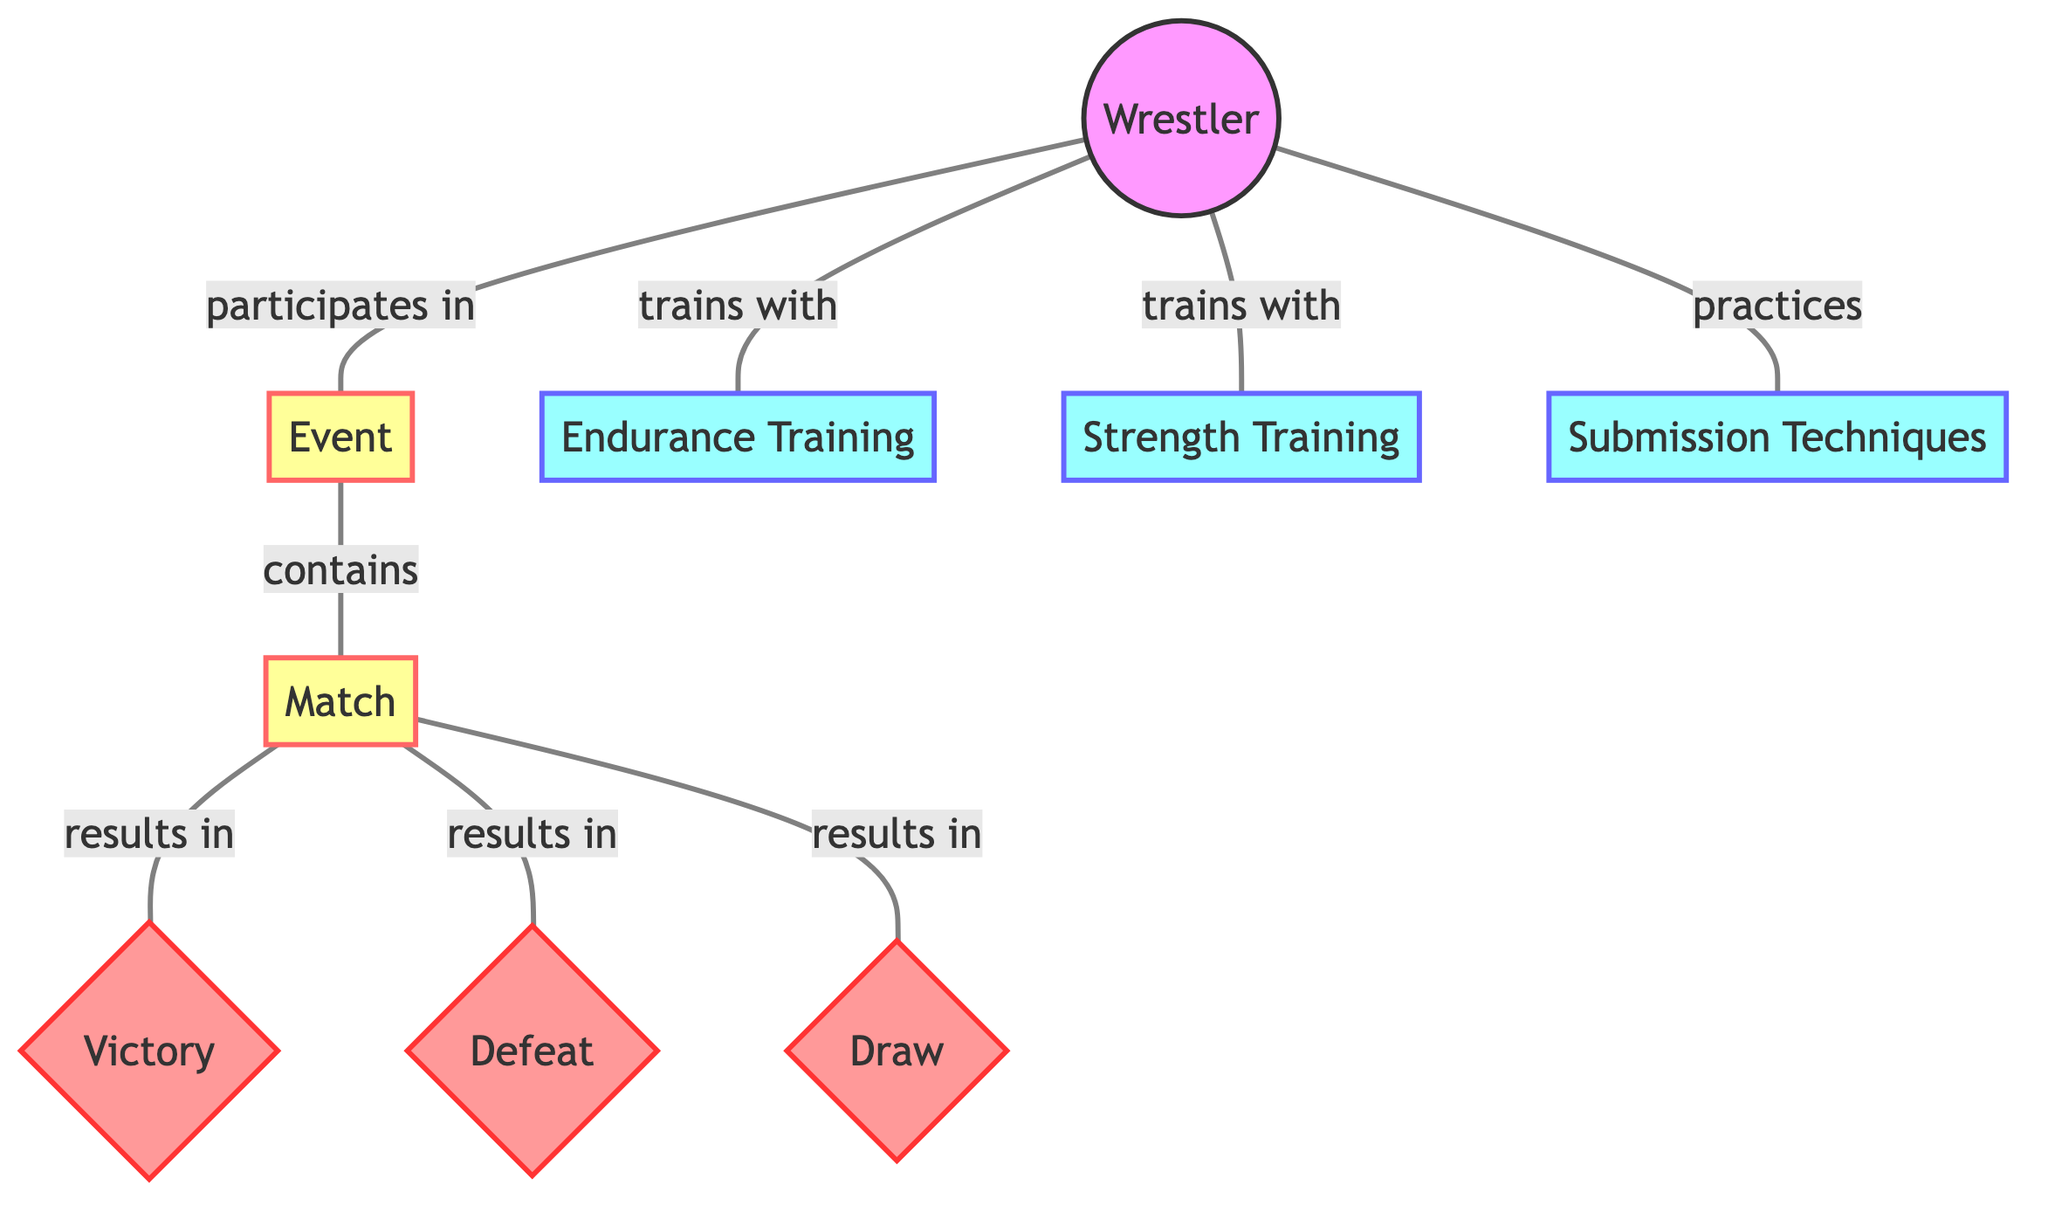What's the total number of nodes in the diagram? The diagram contains 8 distinct entities represented as nodes: Wrestler, Event, Match, Endurance Training, Strength Training, Submission Techniques, Victory, Defeat, and Draw, which can be counted directly from the nodes list.
Answer: 8 How many edges connect the Wrestler node to other nodes? The Wrestler node connects to three different nodes: Event, Endurance Training, Strength Training, and Submission Techniques. Counting these edges gives a total of 4 connections.
Answer: 4 What type of training is associated with the Wrestler? The Wrestler is associated with Endurance Training, Strength Training, and Submission Techniques. Thus, the direct connections can be seen from the edges leading from the Wrestler node to these three training type nodes.
Answer: Endurance Training, Strength Training, Submission Techniques Which outcome can result from a Match? A Match can result in three outcomes which are: Victory, Defeat, and Draw. This information is taken from the connections leading from the Match node to these outcome nodes.
Answer: Victory, Defeat, Draw If a Wrestler participates in an Event, what does that Event contain? An Event contains Matches, which is explicitly stated by the edge connecting the Event node to the Match node. Therefore, participation in an Event directly refers to the Matches contained within it.
Answer: Match What is the relationship between the Match and Victory? The relationship is characterized as "results in," which is indicated by the edge connecting the Match node to the Victory node. This describes the outcome of a Match as leading directly to Victory.
Answer: results in How many different types of outcomes can occur from a single Match? The diagram shows that there are three types of outcomes that can arise from a Match: Victory, Defeat, and Draw. Counting these leads to determining that three outcomes can occur.
Answer: 3 Which nodes are linked directly to the Endurance Training node? The Endurance Training node is directly linked to the Wrestler node, through the edge that specifies that the Wrestler trains with Endurance Training. Hence, the only connection here is to the Wrestler.
Answer: Wrestler What is the connection type from Event to Match? The connection type from Event to Match is "contains," which is described by the edge that connects these two nodes, indicating the structural relationship between the Event and its Matches.
Answer: contains 